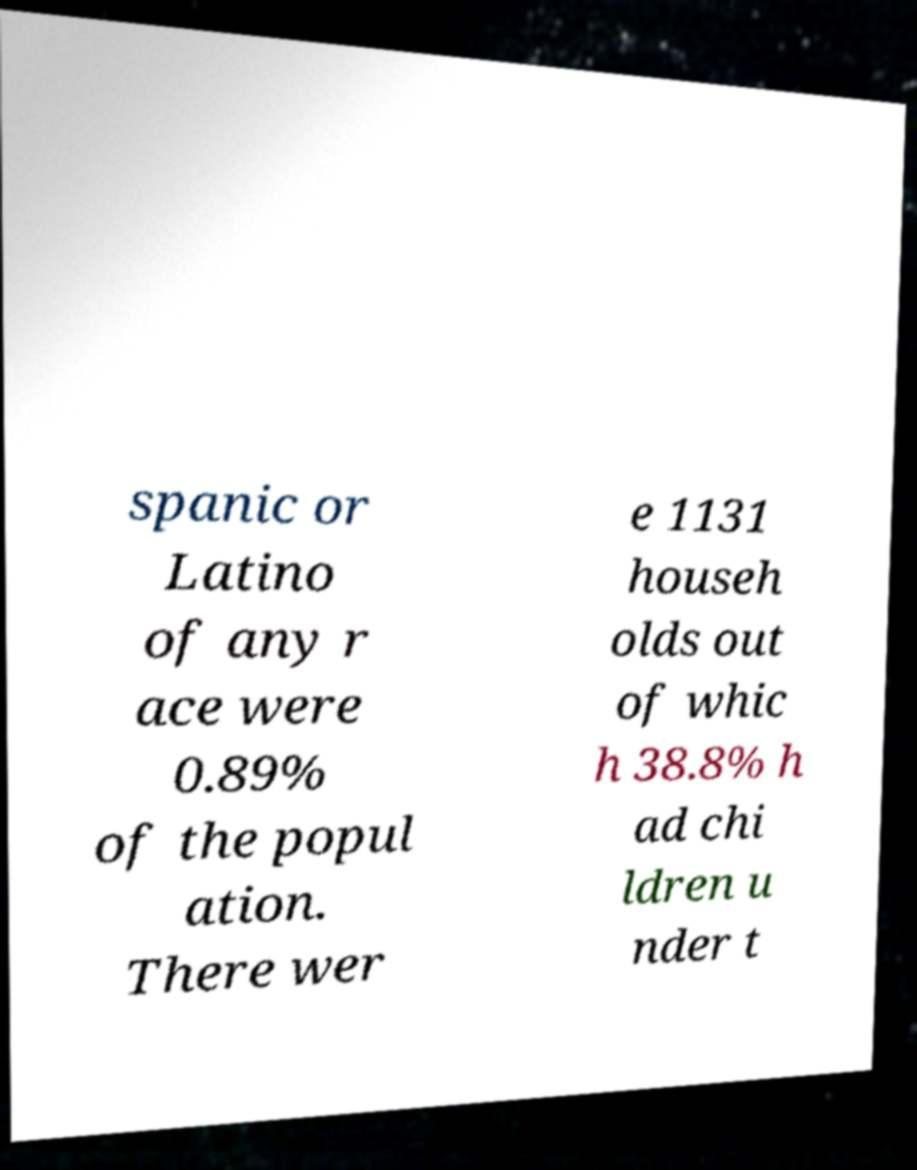Can you accurately transcribe the text from the provided image for me? spanic or Latino of any r ace were 0.89% of the popul ation. There wer e 1131 househ olds out of whic h 38.8% h ad chi ldren u nder t 